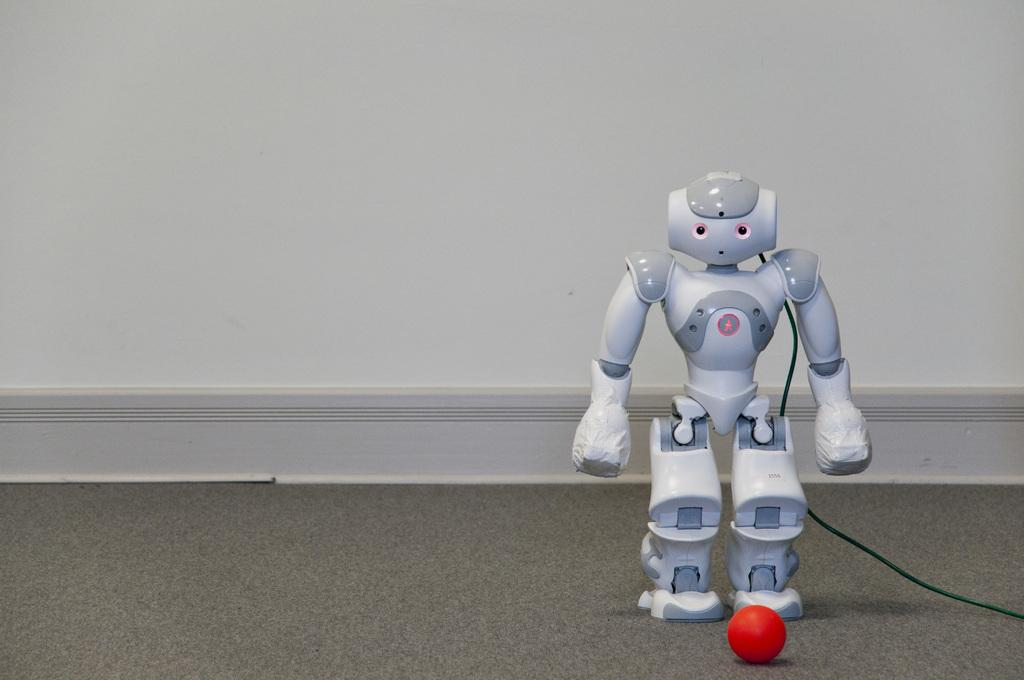What is the main subject in the image? There is a robot in the image. What else can be seen in the image besides the robot? There is a ball in the image. Where are the robot and the ball located? Both the robot and the ball are on the floor. What can be seen in the background of the image? There is a white wall in the background of the image. What color is the destruction caused by the robot in the image? There is no destruction caused by the robot in the image, and therefore, no color can be associated with it. 